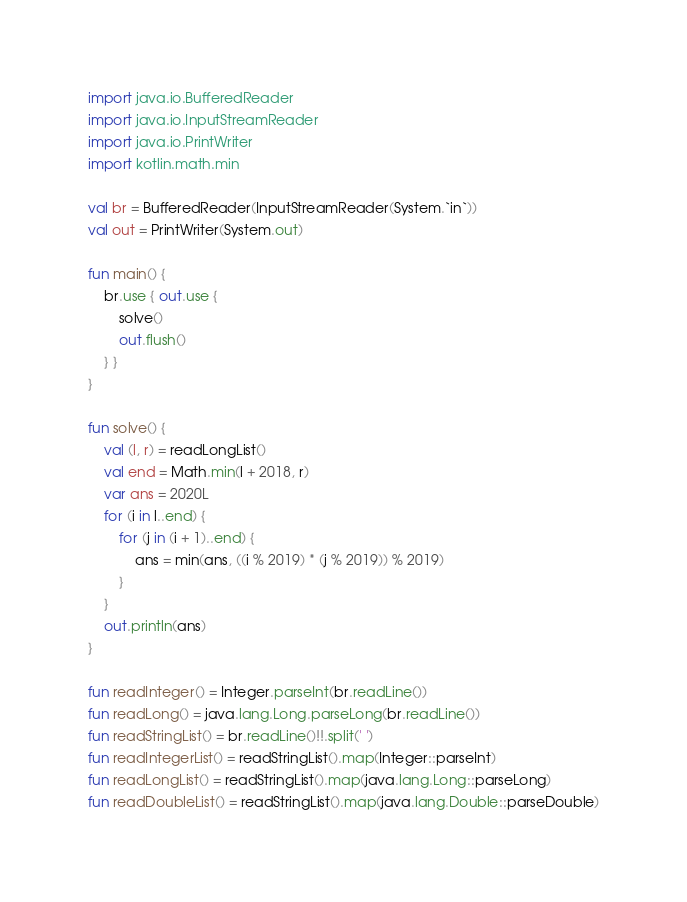Convert code to text. <code><loc_0><loc_0><loc_500><loc_500><_Kotlin_>import java.io.BufferedReader
import java.io.InputStreamReader
import java.io.PrintWriter
import kotlin.math.min

val br = BufferedReader(InputStreamReader(System.`in`))
val out = PrintWriter(System.out)

fun main() {
    br.use { out.use {
        solve()
        out.flush()
    } }
}

fun solve() {
    val (l, r) = readLongList()
    val end = Math.min(l + 2018, r)
    var ans = 2020L
    for (i in l..end) {
        for (j in (i + 1)..end) {
            ans = min(ans, ((i % 2019) * (j % 2019)) % 2019)
        }
    }
    out.println(ans)
}

fun readInteger() = Integer.parseInt(br.readLine())
fun readLong() = java.lang.Long.parseLong(br.readLine())
fun readStringList() = br.readLine()!!.split(' ')
fun readIntegerList() = readStringList().map(Integer::parseInt)
fun readLongList() = readStringList().map(java.lang.Long::parseLong)
fun readDoubleList() = readStringList().map(java.lang.Double::parseDouble)
</code> 